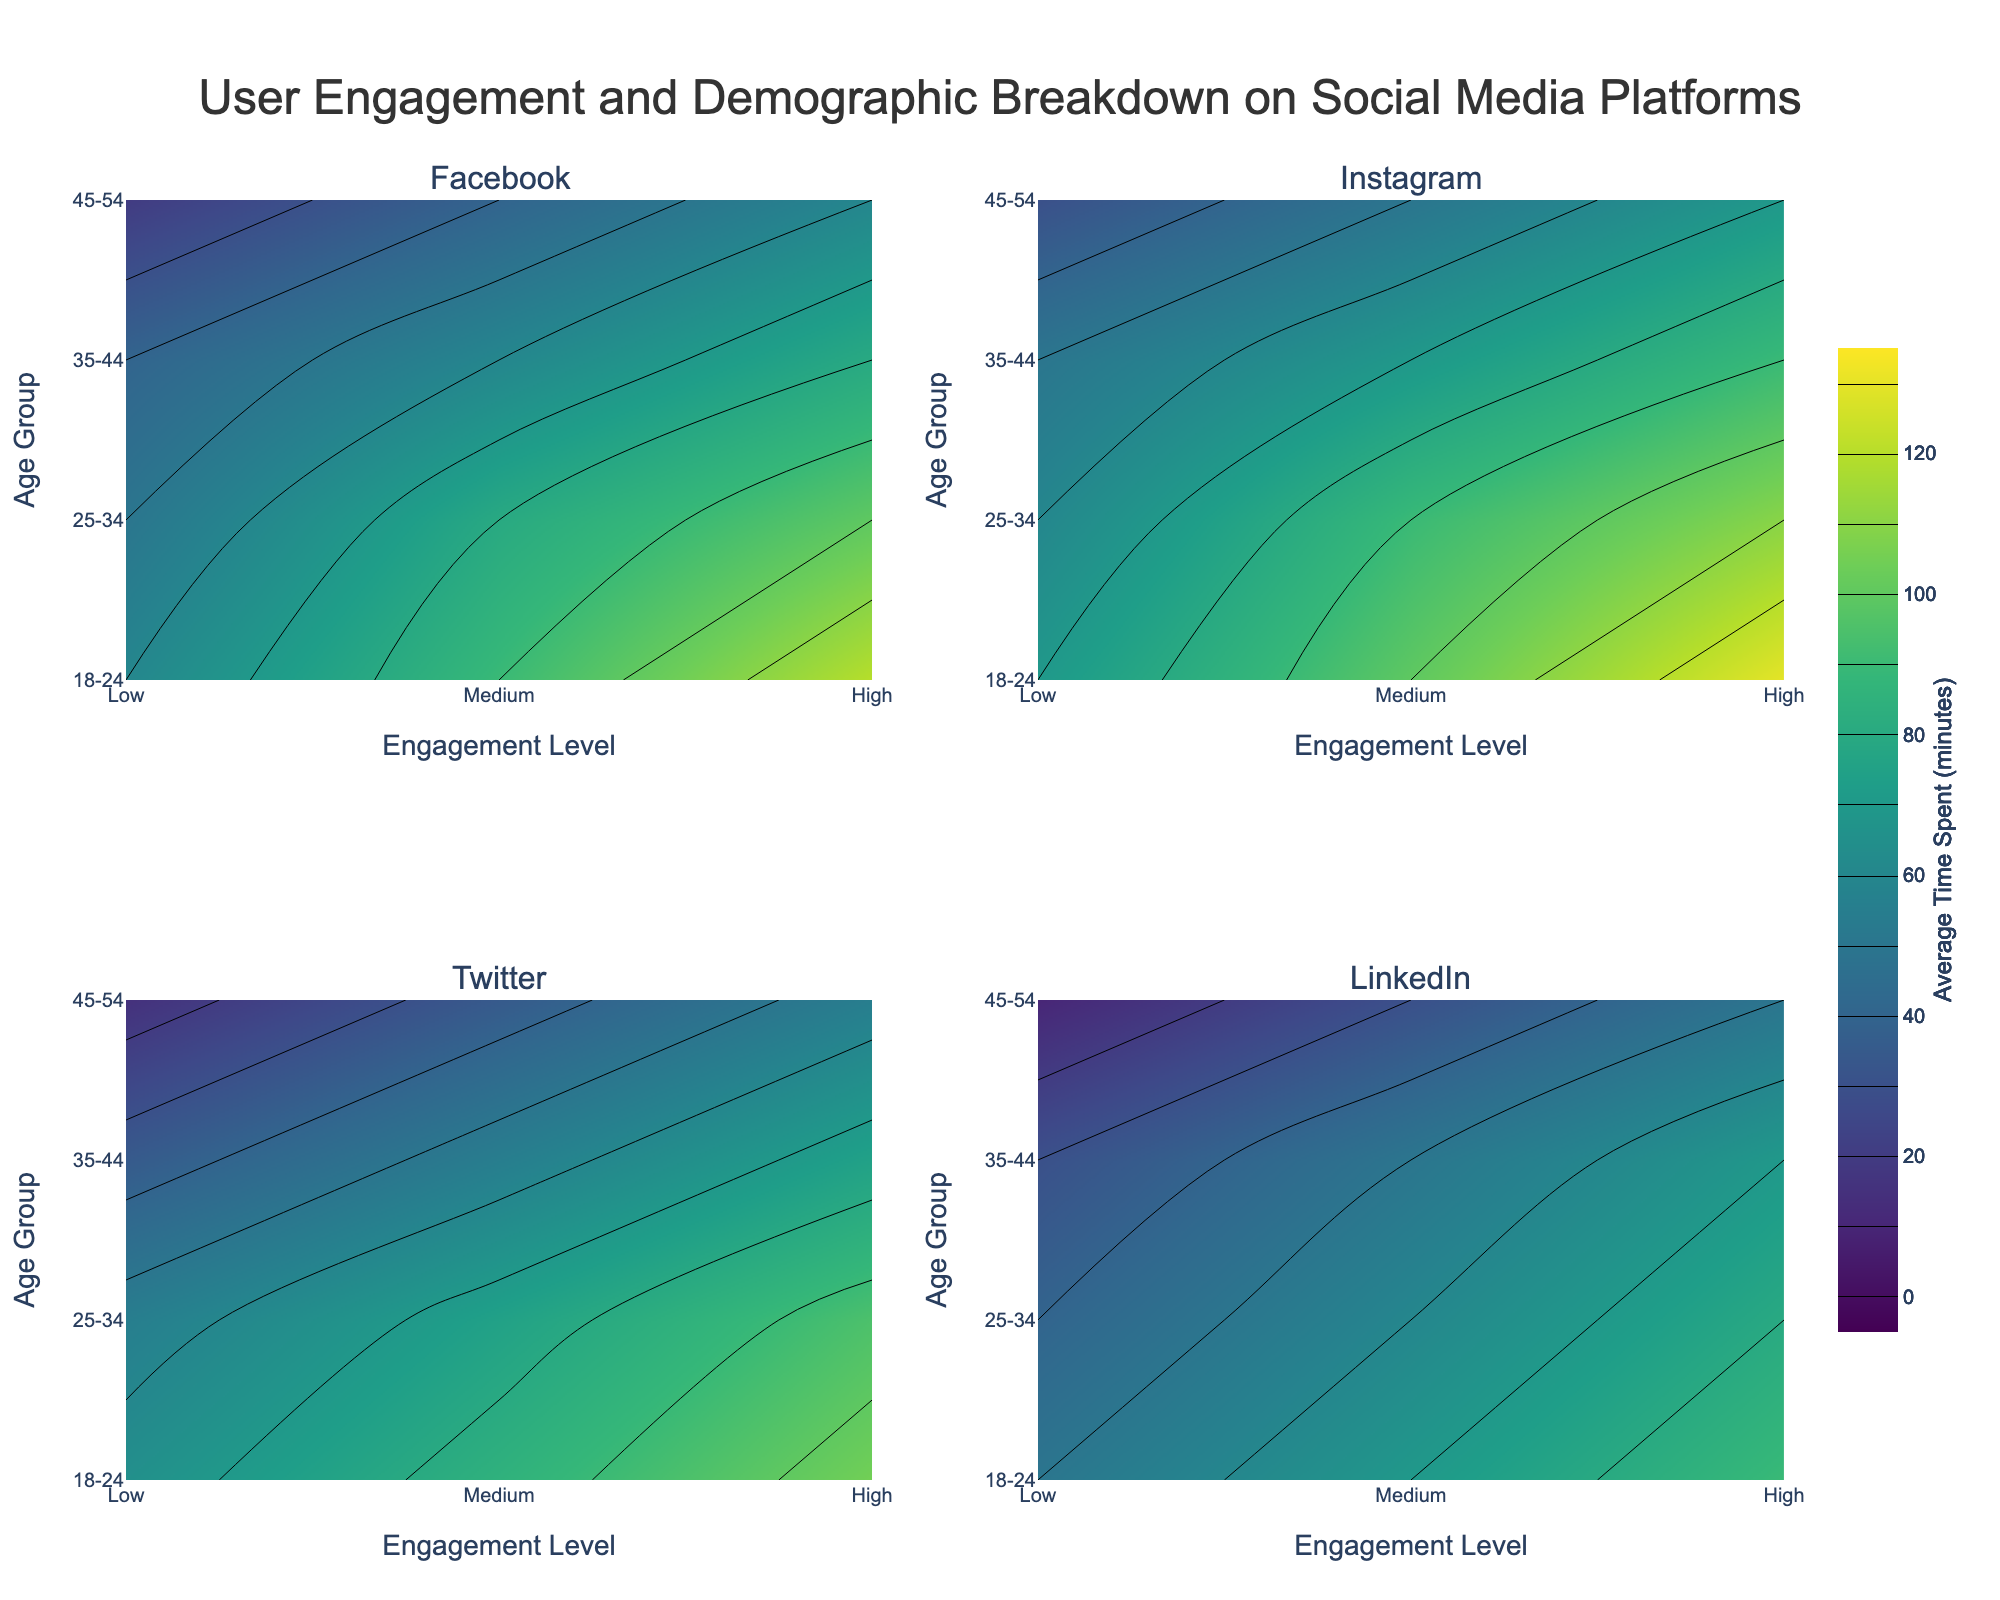What is the title of the figure? The title is located at the top center of the figure. It clearly describes the content and purpose of the figure.
Answer: User Engagement and Demographic Breakdown on Social Media Platforms What are the x and y axes labeled in the subplots? Each subplot has its x-axis labeled as "Engagement Level" and its y-axis labeled as "Age Group". This is consistent across all four subplots.
Answer: Engagement Level and Age Group Which social media platform has the highest average time spent for the '18-24' age group with 'High' engagement? By observing the contour plots, the highest average time spent for the '18-24' age group with 'High' engagement is on the Instagram subplot, highlighted by the contour color.
Answer: Instagram For the age group '35-44', which platform has the lowest average time spent at a 'Medium' engagement level? By comparing the contours at the '35-44' age group and 'Medium' engagement level, the LinkedIn subplot shows the lowest average time spent.
Answer: LinkedIn How does the average time spent on Twitter compare between the '25-34' and '45-54' age groups at a 'High' engagement level? Looking at the contour plot for Twitter, the '25-34' age group spends 95 minutes on average, while the '45-54' age group spends 55 minutes at a 'High' engagement level.
Answer: 95 (25-34) vs. 55 (45-54) Which age group on Facebook shows the largest variation in average time spent across different engagement levels? Inspecting the Facebook subplot, the '18-24' age group shows the largest range of average time spent, varying from 60 to 120 minutes across different engagement levels.
Answer: 18-24 What is the general trend in average time spent as the age group increases on LinkedIn with a 'Low' engagement level? By examining the LinkedIn subplot, the general trend shows that average time spent decreases as the age group increases at a 'Low' engagement level.
Answer: Decreasing Between Instagram and Facebook, which platform shows a greater color gradient difference for 'Medium' engagement levels across all age groups? Comparing the contours, Instagram shows a more pronounced color gradient difference for 'Medium' engagement levels across all age groups compared to Facebook.
Answer: Instagram 